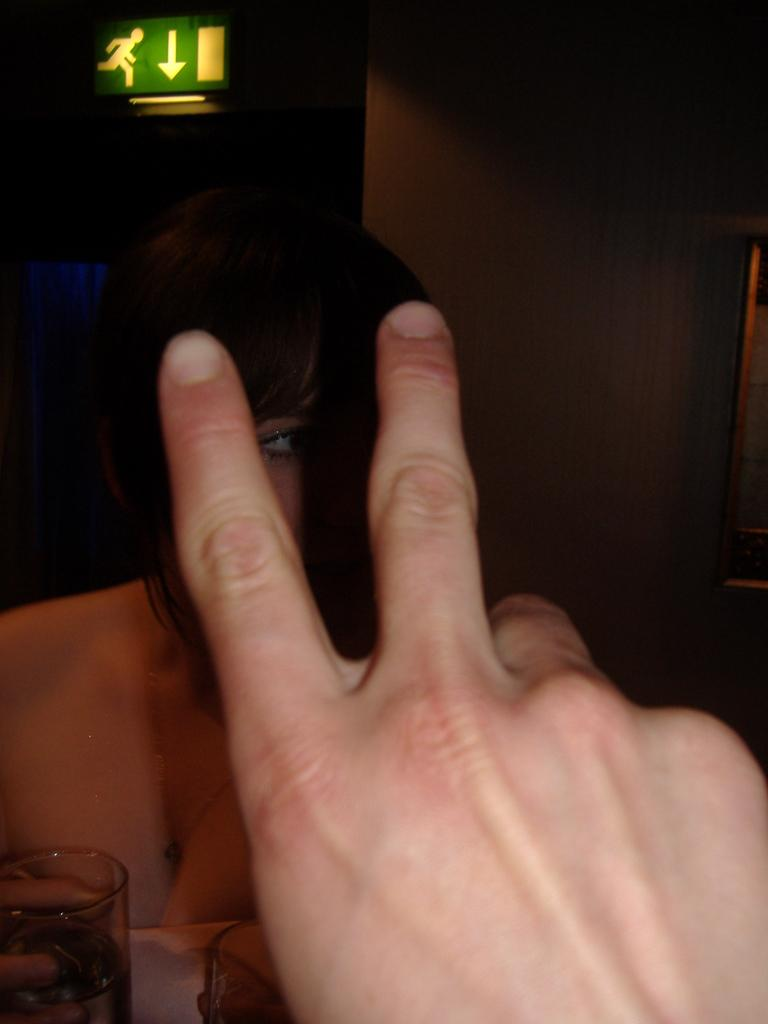What is located in the front of the image? There is a hand in the front of the image. What is the lady in the image doing? The lady is sitting in the image. What is the lady holding in the image? The lady is holding a wine glass. What can be seen behind the lady in the image? There is a wall in the image. What safety measure is present in the image? There is a caution board on the ceiling in the image. Can you tell me how many flights the lady's dad took last year? There is no information about flights or the lady's dad in the image, so we cannot answer that question. What type of pest is visible on the caution board in the image? There is no pest visible on the caution board in the image; it is a safety measure with no living organisms present. 